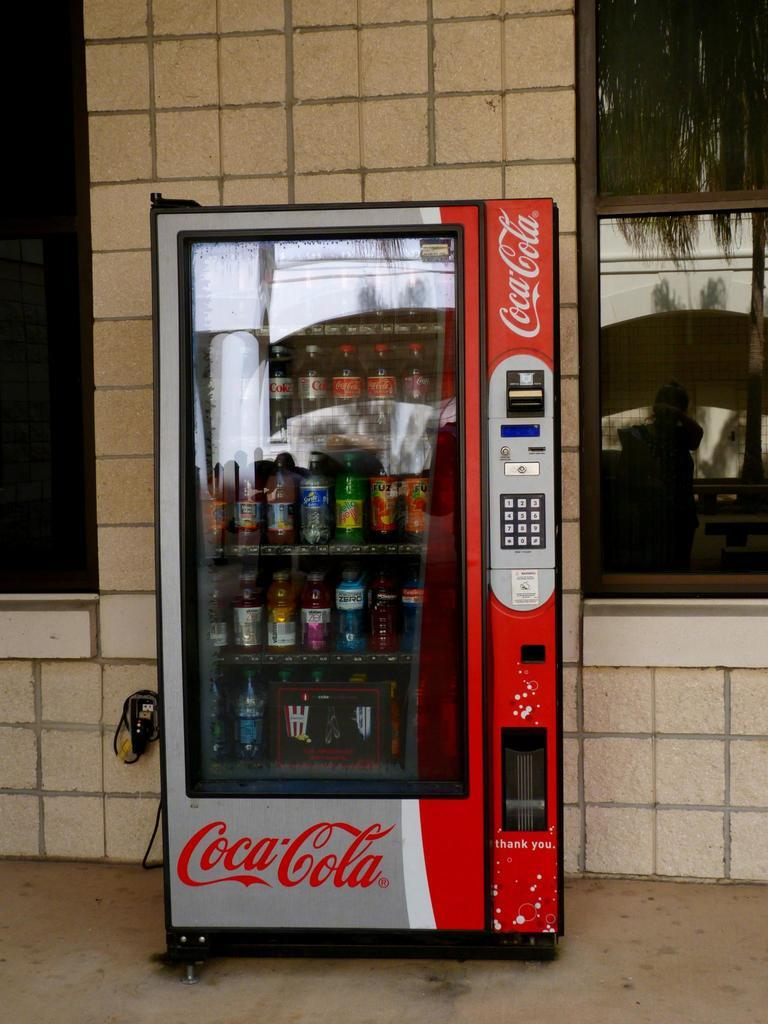What can be found inside the vending machine in the image? There are bottles in a vending machine in the image. What can be seen in the background of the image? There is a wall with windows in the background of the image. What type of fan is visible in the image? There is no fan present in the image. Can you describe the veins in the bottles in the image? The bottles in the image do not have veins; they are inanimate objects. 